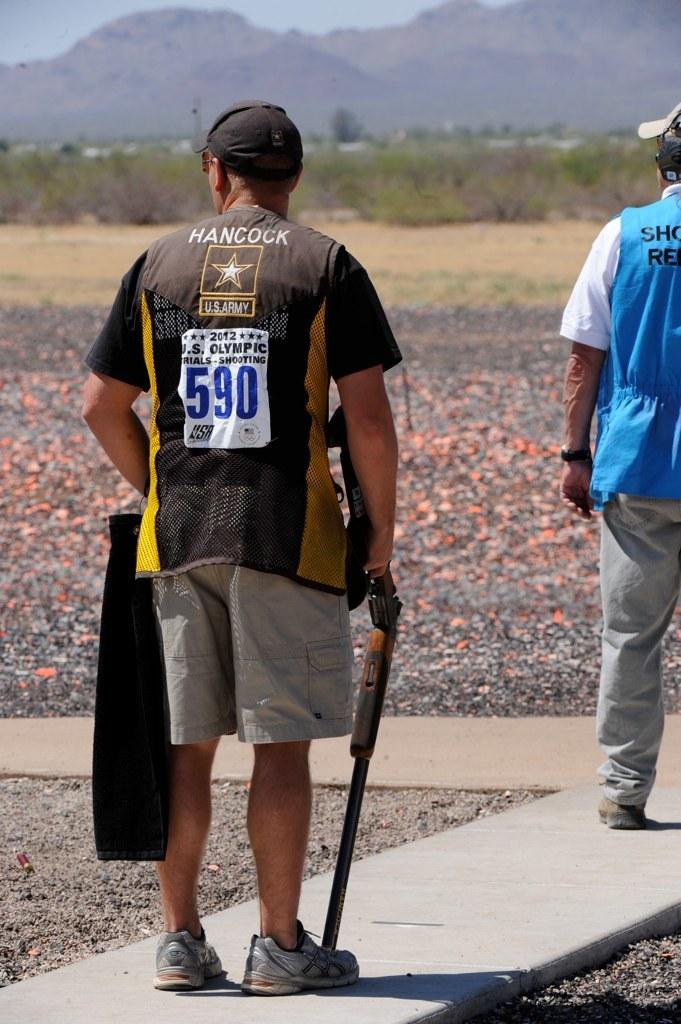<image>
Render a clear and concise summary of the photo. A man wearing a tag on the back of his shirt with the number 590 underneath the United States Army symbol, is holding a rifle in his right hand. 